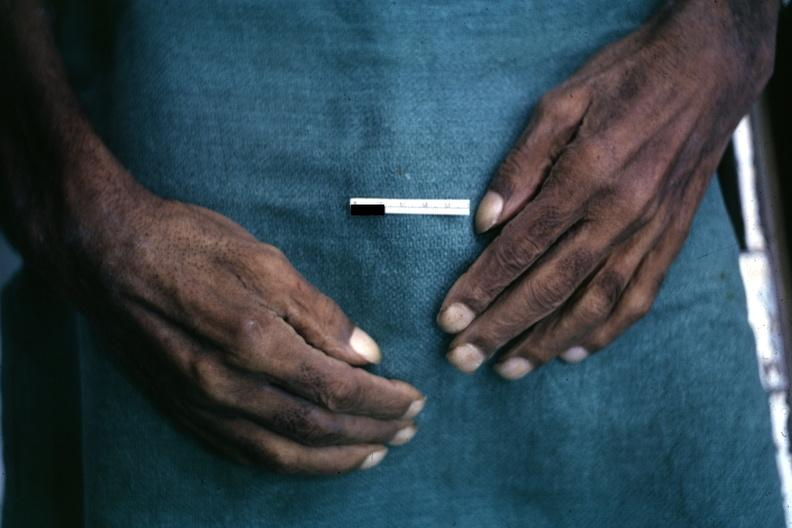s hand present?
Answer the question using a single word or phrase. Yes 